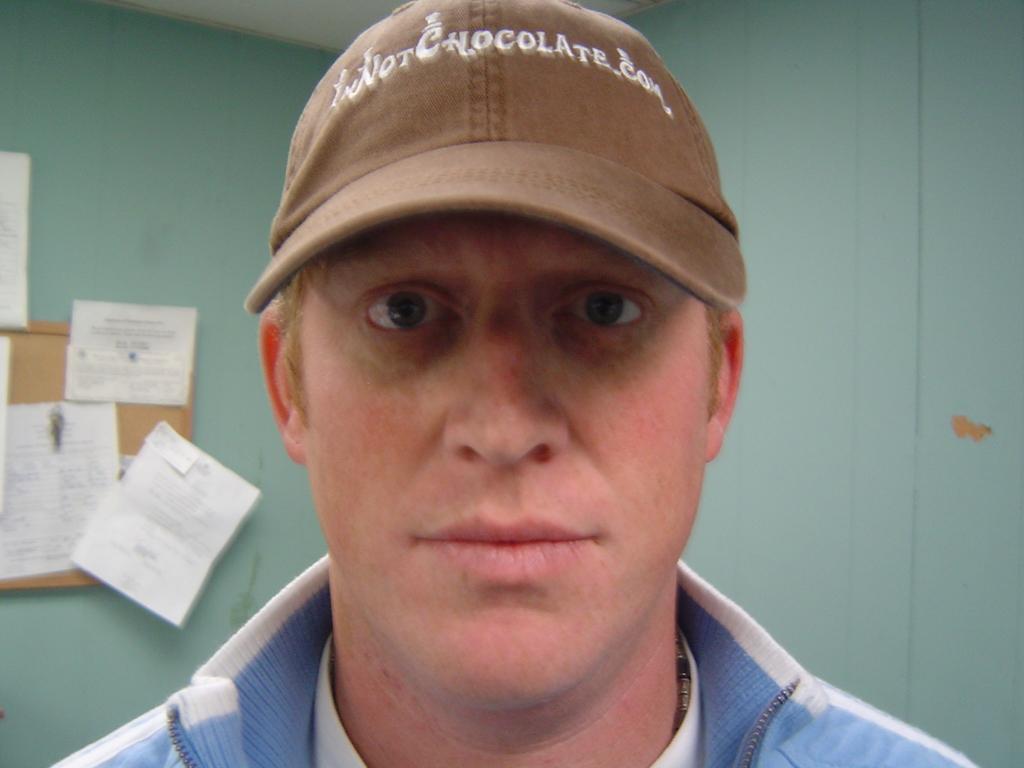Can you describe this image briefly? In this image we can see a person wearing a cap, behind him we can see the walls, and some pamphlets on a wooden board. 